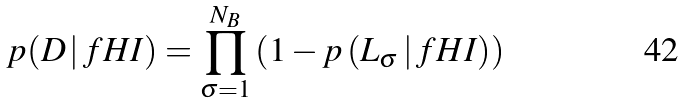<formula> <loc_0><loc_0><loc_500><loc_500>p ( D \, | \, f H I ) = \prod _ { \sigma = 1 } ^ { N _ { B } } \left ( 1 - p \left ( L _ { \sigma } \, | \, f H I \right ) \right )</formula> 